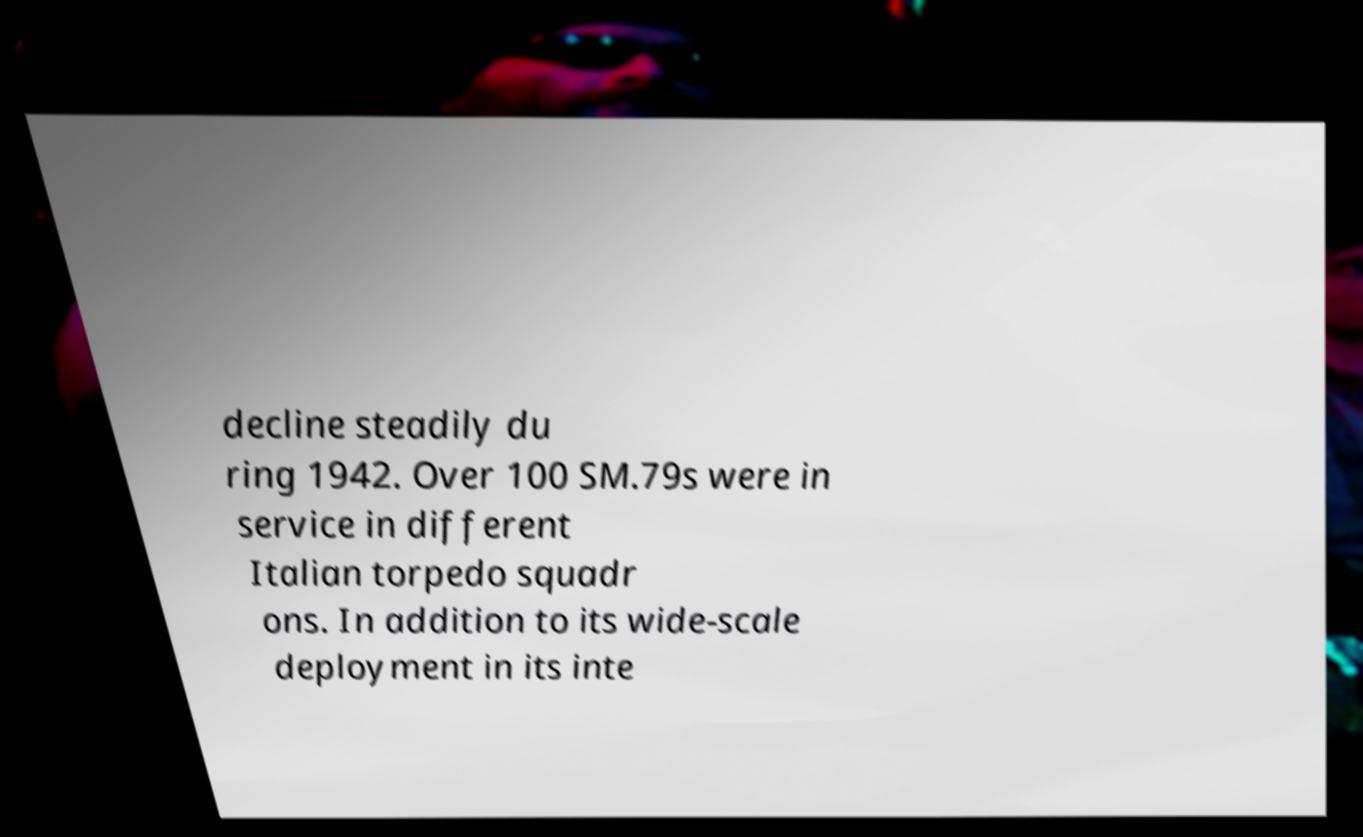There's text embedded in this image that I need extracted. Can you transcribe it verbatim? decline steadily du ring 1942. Over 100 SM.79s were in service in different Italian torpedo squadr ons. In addition to its wide-scale deployment in its inte 